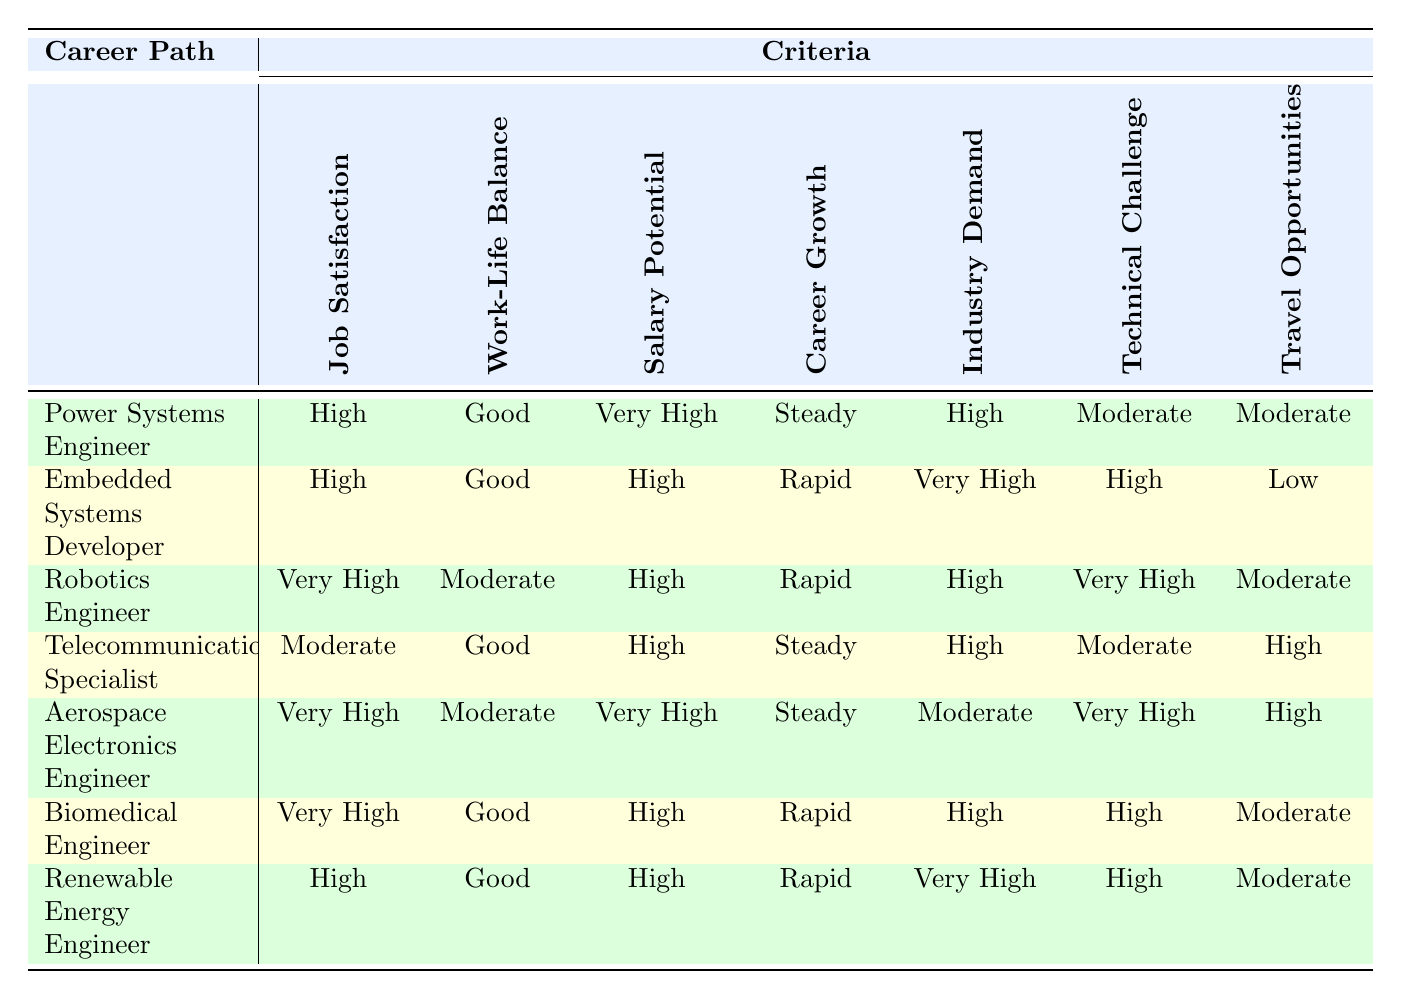What is the job satisfaction level for Biomedical Engineer? The table shows that the job satisfaction level for Biomedical Engineer is "Very High".
Answer: Very High Which career path has the highest salary potential? "Power Systems Engineer" and "Aerospace Electronics Engineer" both have "Very High" salary potential, which is the highest level shown.
Answer: Power Systems Engineer, Aerospace Electronics Engineer Is the work-life balance for Telecommunications Specialist good? The table indicates that the work-life balance for Telecommunications Specialist is "Good", affirming that it is indeed good.
Answer: Yes Which career path offers the highest technical challenge? The highest technical challenge is indicated as "Very High" for both Robotics Engineer and Aerospace Electronics Engineer.
Answer: Robotics Engineer, Aerospace Electronics Engineer What is the average salary potential for careers with "High" salary potential? The careers with "High" salary potential are Embedded Systems Developer, Robotics Engineer, Telecommunications Specialist, Biomedical Engineer, and Renewable Energy Engineer. Their salary potentials sum to (High + High + High + High + High) which is a qualitative average, remaining at "High".
Answer: High Is there a career path with rapid career growth and low travel opportunities? The "Embedded Systems Developer" has rapid career growth but low travel opportunities, confirming this requirement.
Answer: Yes What is the career path with the least travel opportunities? "Embedded Systems Developer" has the least travel opportunities listed as "Low".
Answer: Embedded Systems Developer Which is the only career path with a "Moderate" industry demand? The only career path listed with "Moderate" industry demand is "Aerospace Electronics Engineer".
Answer: Aerospace Electronics Engineer Which two career paths offer a "Good" work-life balance? The careers that show a "Good" work-life balance in the table are Power Systems Engineer, Telecommunications Specialist, Biomedical Engineer, and Renewable Energy Engineer, giving us a total of four paths.
Answer: Power Systems Engineer, Telecommunications Specialist, Biomedical Engineer, Renewable Energy Engineer 